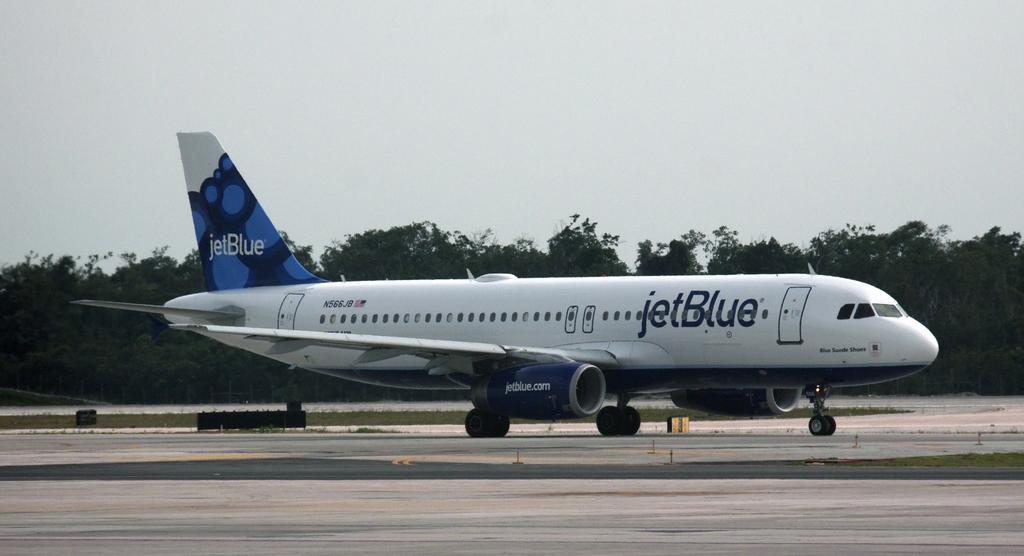Please provide a concise description of this image. In this picture I can see the passenger plane on the runway. In the background I can see many trees, plants and grass. At the top I can see the sky and clouds. 